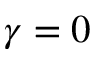Convert formula to latex. <formula><loc_0><loc_0><loc_500><loc_500>\gamma = 0</formula> 